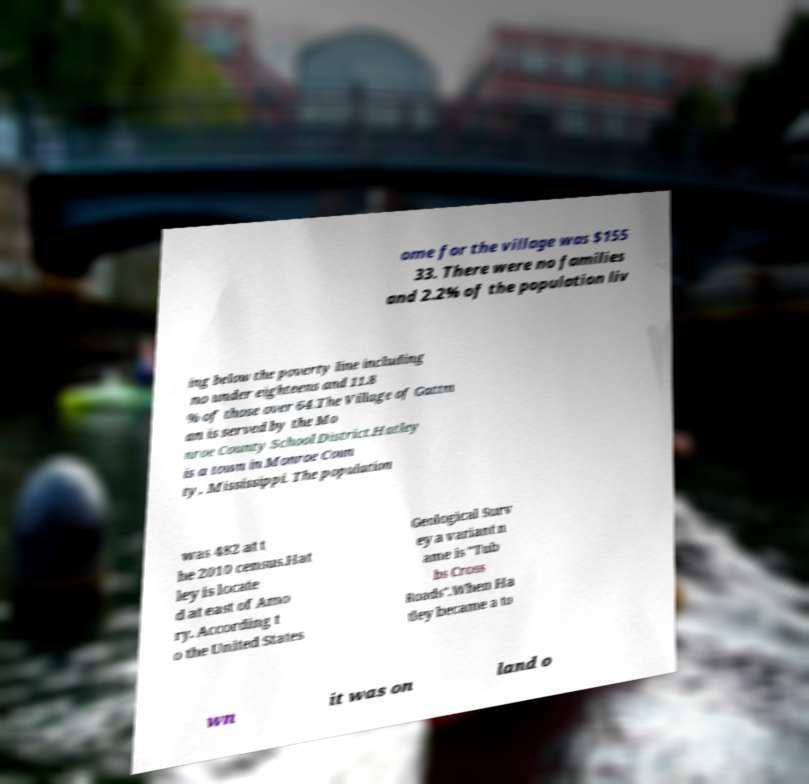Please read and relay the text visible in this image. What does it say? ome for the village was $155 33. There were no families and 2.2% of the population liv ing below the poverty line including no under eighteens and 11.8 % of those over 64.The Village of Gattm an is served by the Mo nroe County School District.Hatley is a town in Monroe Coun ty, Mississippi. The population was 482 at t he 2010 census.Hat ley is locate d at east of Amo ry. According t o the United States Geological Surv ey a variant n ame is "Tub bs Cross Roads".When Ha tley became a to wn it was on land o 